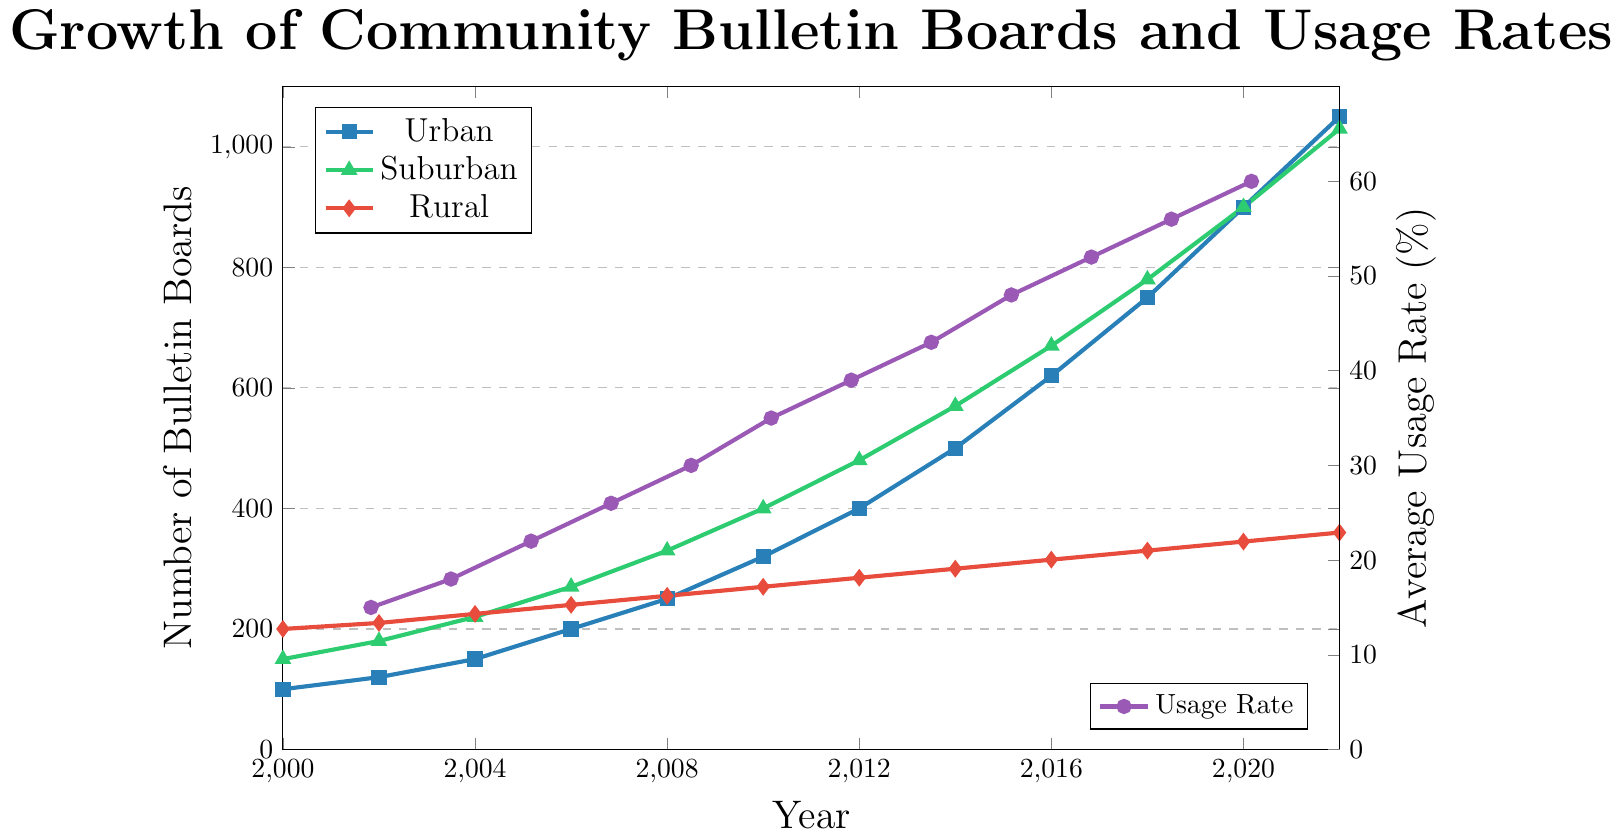How many more bulletin boards were there in urban areas compared to rural areas in 2022? According to the figure, there were 1050 bulletin boards in urban areas and 360 in rural areas in 2022. The difference is 1050 - 360 = 690
Answer: 690 What is the overall trend of the average usage rate from 2000 to 2022? From the figure, the average usage rate shows a clear upward trend, increasing from 15% in 2000 to 60% in 2022. The consistent increase indicates a growing interest and utilization of community bulletin boards over time.
Answer: Upward trend Which neighborhood had the highest number of bulletin boards in 2016? According to the figure, suburban areas had the highest number of bulletin boards in 2016 with 670, followed by urban areas with 620, and rural areas with 315.
Answer: Suburban How much did the average usage rate increase between 2002 and 2012? The average usage rate in 2002 was 18%, and in 2012 it was 39%. The increase is calculated as 39% - 18% = 21%.
Answer: 21% Which neighborhood showed the slowest growth in the number of bulletin boards over the entire period? From 2000 to 2022, rural areas showed the slowest growth, increasing from 200 to 360 bulletin boards. By comparison, urban and suburban areas showed more significant increases.
Answer: Rural In which year did urban areas see the largest increase in bulletin boards compared to the previous year? By examining the chart, the largest increase in urban bulletin boards occurred between 2018 and 2020, where the number grew from 750 to 900, an increase of 150.
Answer: 2018-2020 What was the combined total number of bulletin boards in all neighborhoods in 2010? In 2010, the number of bulletin boards were 320 (urban), 400 (suburban), and 270 (rural). Adding these gives 320 + 400 + 270 = 990.
Answer: 990 Do urban or suburban areas have a steeper growth curve over time? Comparing the slopes of the lines in the figure, suburban areas exhibit a steeper growth curve than urban areas over the time period, especially noticeable from 2012 onwards.
Answer: Suburban 